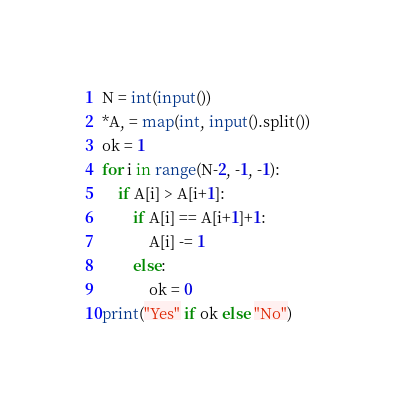Convert code to text. <code><loc_0><loc_0><loc_500><loc_500><_Python_>N = int(input())
*A, = map(int, input().split())
ok = 1
for i in range(N-2, -1, -1):
    if A[i] > A[i+1]:
        if A[i] == A[i+1]+1:
            A[i] -= 1
        else:
            ok = 0
print("Yes" if ok else "No")</code> 